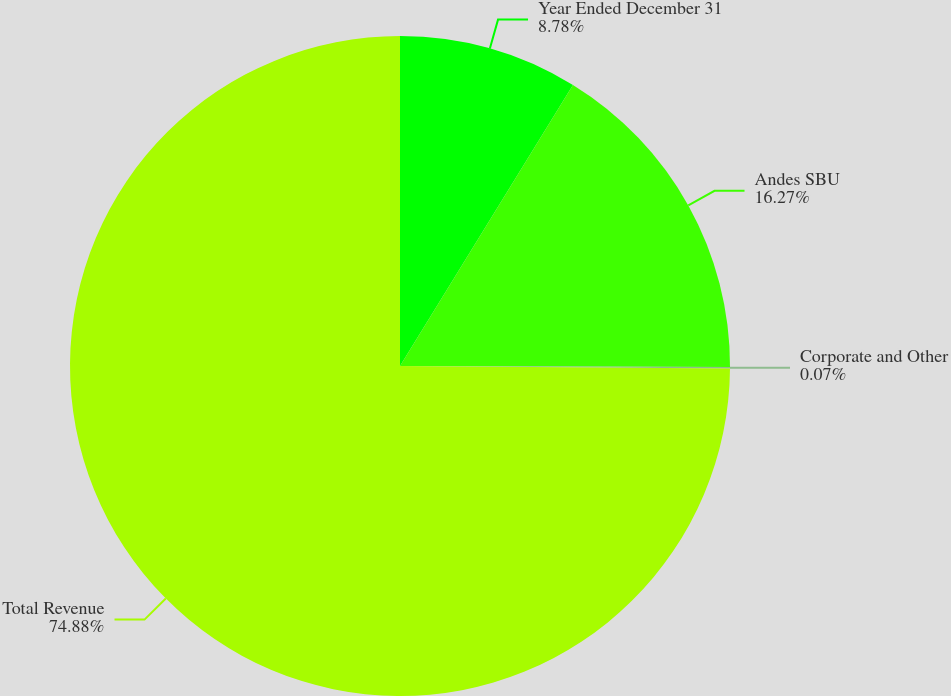Convert chart to OTSL. <chart><loc_0><loc_0><loc_500><loc_500><pie_chart><fcel>Year Ended December 31<fcel>Andes SBU<fcel>Corporate and Other<fcel>Total Revenue<nl><fcel>8.78%<fcel>16.27%<fcel>0.07%<fcel>74.89%<nl></chart> 